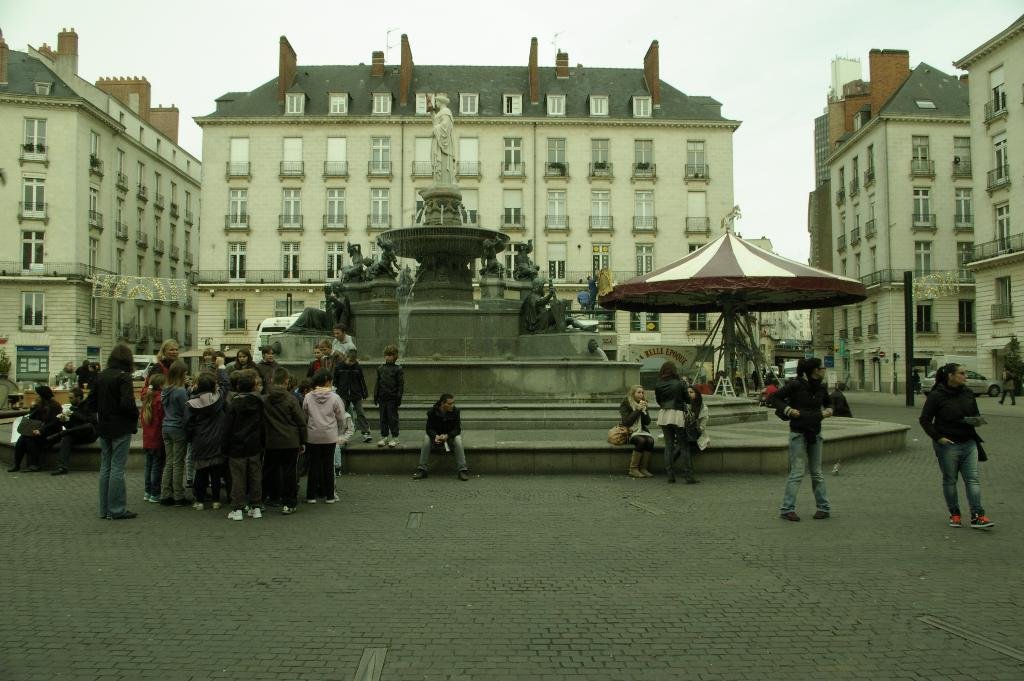What type of structures can be seen in the image? There are buildings in the image. What is located on the road in the image? There is a statue on the road in the image. Who or what is present on the road in the image? There are people on the road in the image. What type of structure is located to the side of the road in the image? There is a shed to the side of the road in the image. What type of fiction is being read by the statue in the image? There is no indication that the statue is reading fiction or any other type of material in the image. How does the shed affect the acoustics of the area in the image? The provided facts do not give any information about the acoustics of the area or the shed's impact on it. 